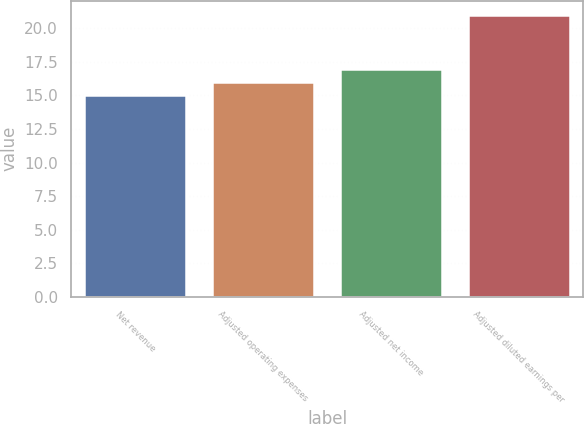<chart> <loc_0><loc_0><loc_500><loc_500><bar_chart><fcel>Net revenue<fcel>Adjusted operating expenses<fcel>Adjusted net income<fcel>Adjusted diluted earnings per<nl><fcel>15<fcel>16<fcel>17<fcel>21<nl></chart> 